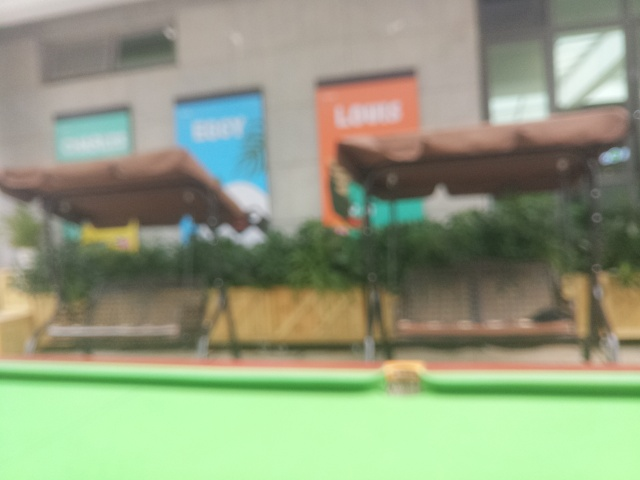Can you suggest how this image might be used despite its blurriness? Though the image is blurry, it can still be used in contexts where high detail is not essential. For example, it could serve as a background image where focus is not crucial, or in artistic settings where it might be used to evoke a sense of motion or abstract qualities. 